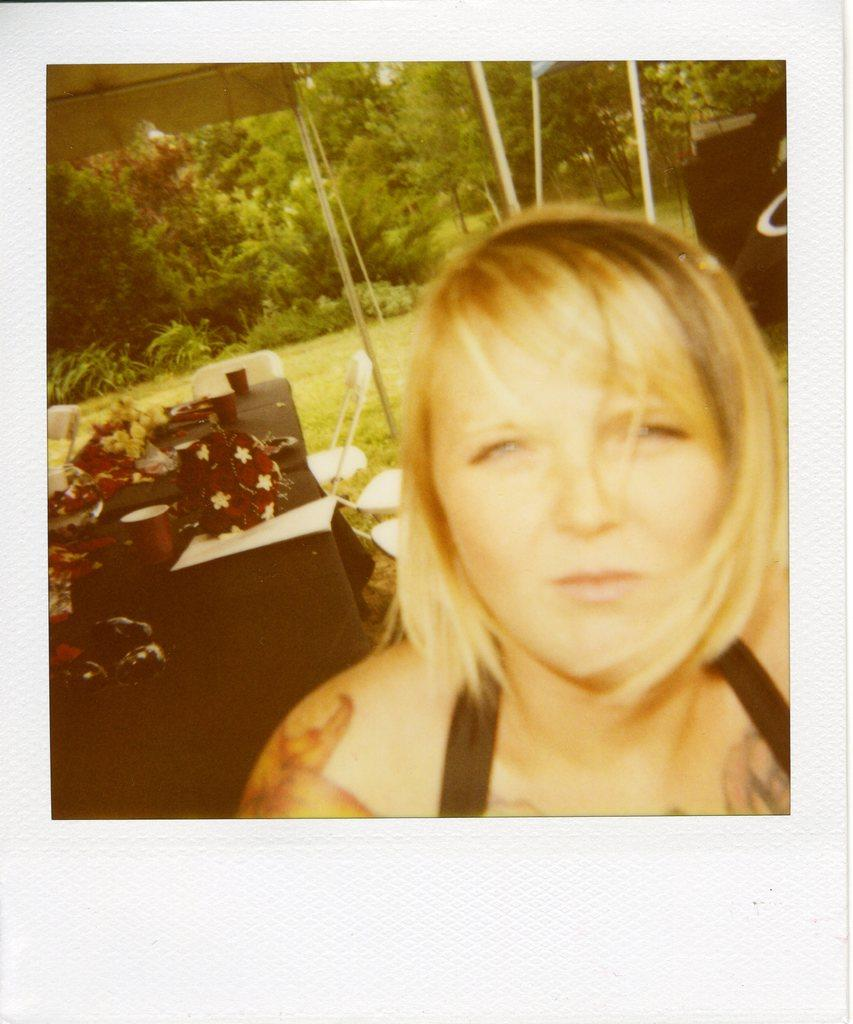Who is present in the image? There is a woman in the image. What is the woman doing in the image? The woman is watching something. What can be seen on the table in the background? There are cups and other objects on a table in the background. What type of vegetation is visible in the background? There are plants, trees, and grass on the ground in the background. What time of day is it in the image, and what is the woman using to soak up the afternoon sun? The time of day is not mentioned in the image, and there is no sponge or indication of the woman soaking up the sun. 